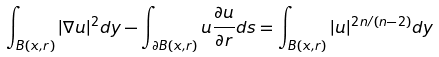Convert formula to latex. <formula><loc_0><loc_0><loc_500><loc_500>\int _ { B ( x , r ) } { | \nabla { u } | ^ { 2 } } d y - \int _ { \partial { B ( x , r ) } } { u \frac { \partial { u } } { \partial { r } } } d s = \int _ { B ( x , r ) } { | u | ^ { 2 n / ( n - 2 ) } } d y</formula> 